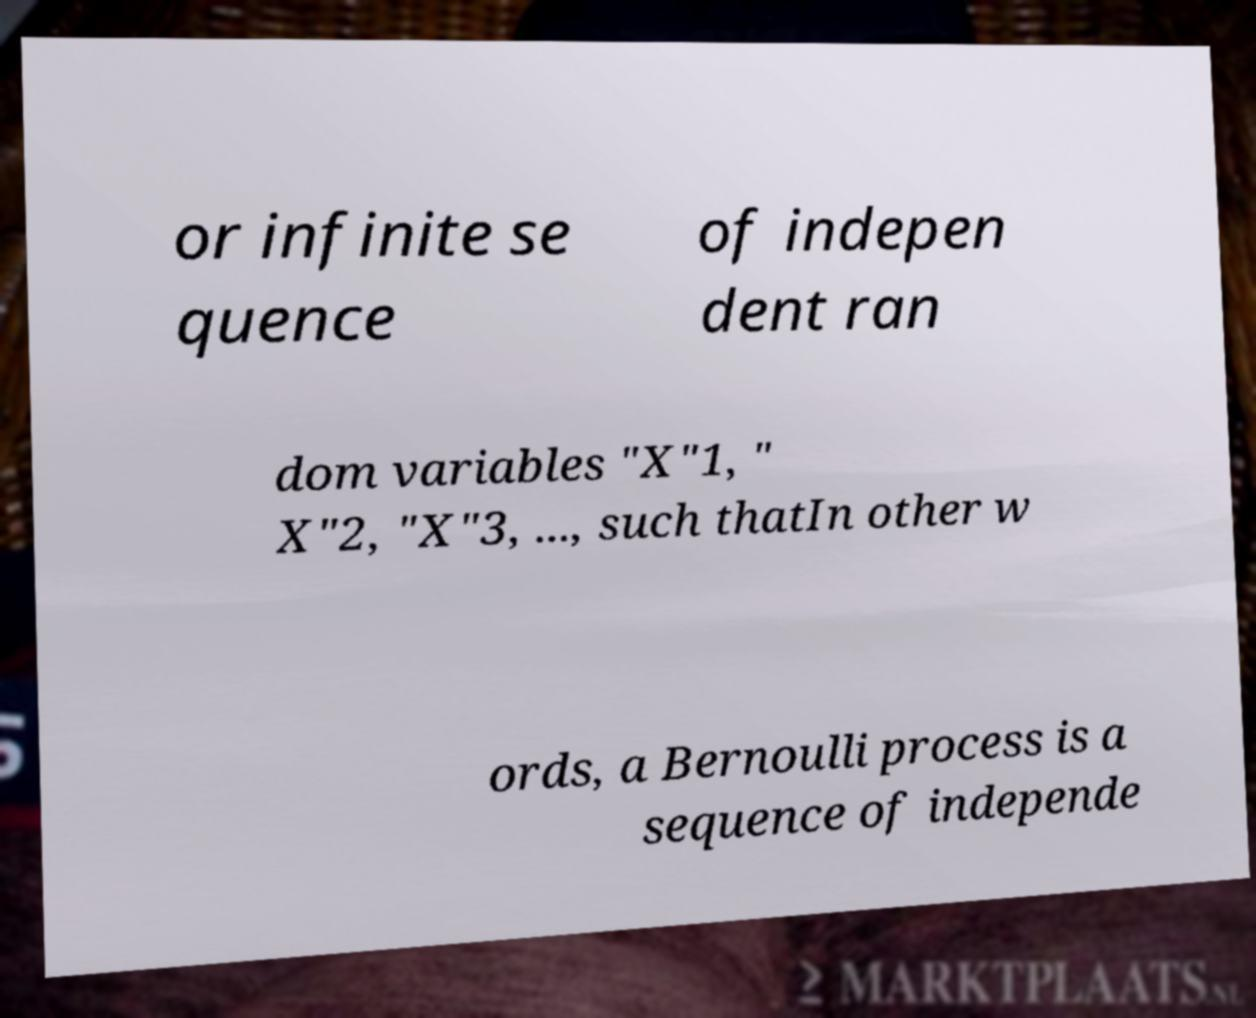Please identify and transcribe the text found in this image. or infinite se quence of indepen dent ran dom variables "X"1, " X"2, "X"3, ..., such thatIn other w ords, a Bernoulli process is a sequence of independe 